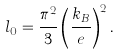Convert formula to latex. <formula><loc_0><loc_0><loc_500><loc_500>l _ { 0 } = \frac { \pi ^ { 2 } } { 3 } \left ( \frac { k _ { B } } { e } \right ) ^ { 2 } .</formula> 